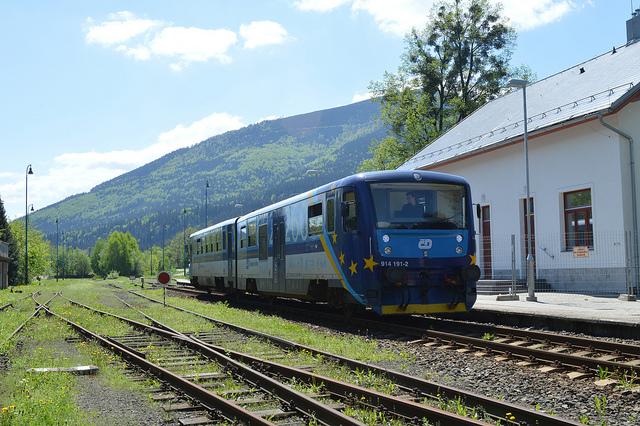What is the color of the train?
Keep it brief. Blue. How many tracks are in the shot?
Keep it brief. 4. IS there clouds in the sky?
Answer briefly. Yes. Is this an urban train station?
Short answer required. No. 